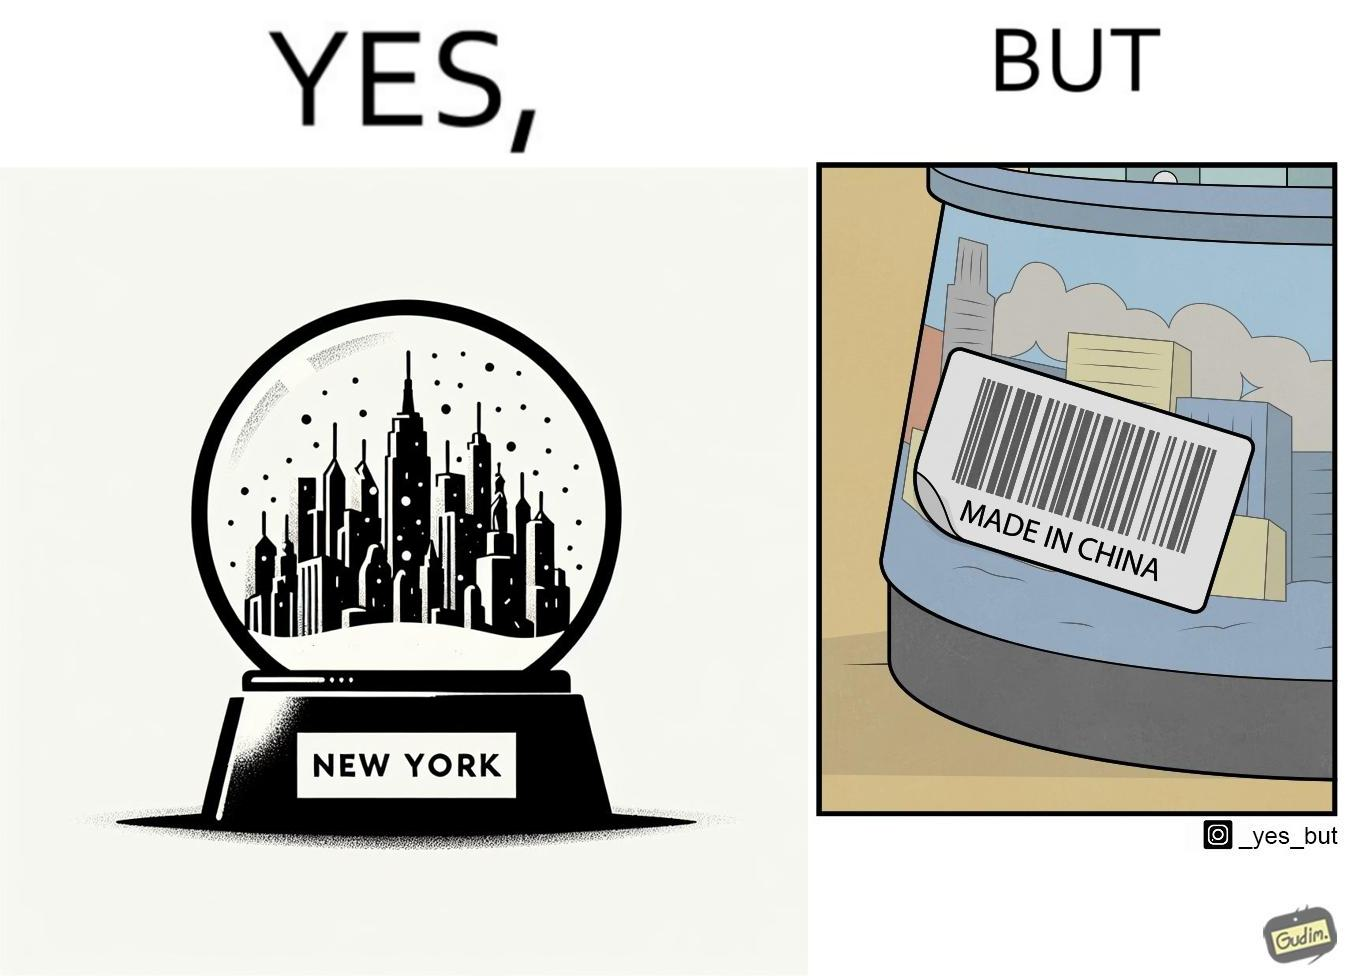Is this image satirical or non-satirical? Yes, this image is satirical. 